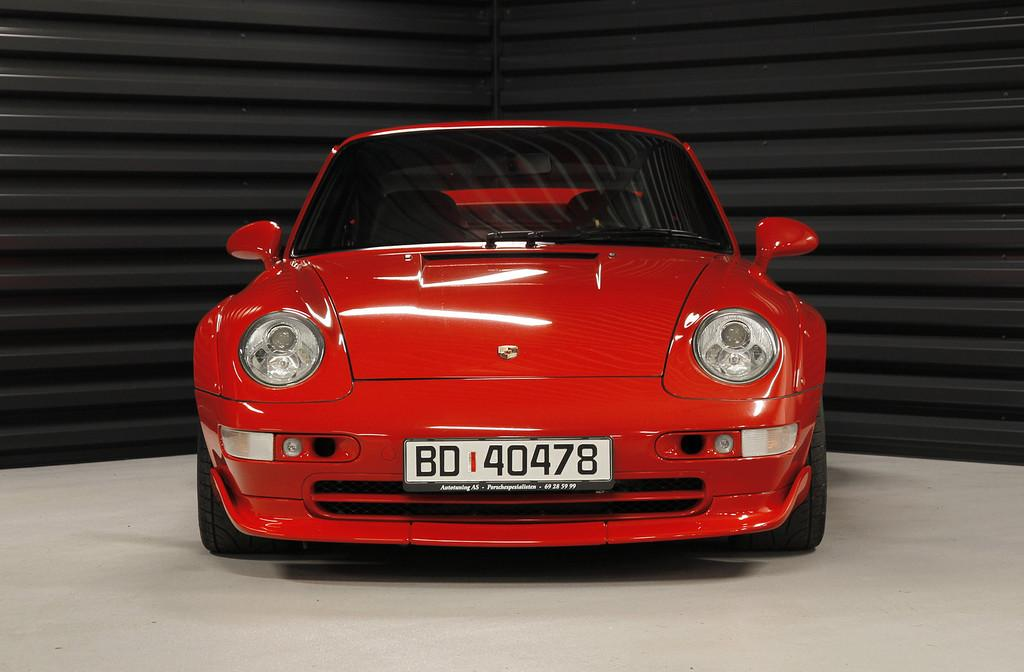What color can be seen on the floor in the image? There is a red color on the floor in the image. What type of structure is visible in the background of the image? There is a metal wall-like structure in the background of the image. What type of vest is being sold at the market in the image? There is no market or vest present in the image; it only features a red color on the floor and a metal wall-like structure in the background. 